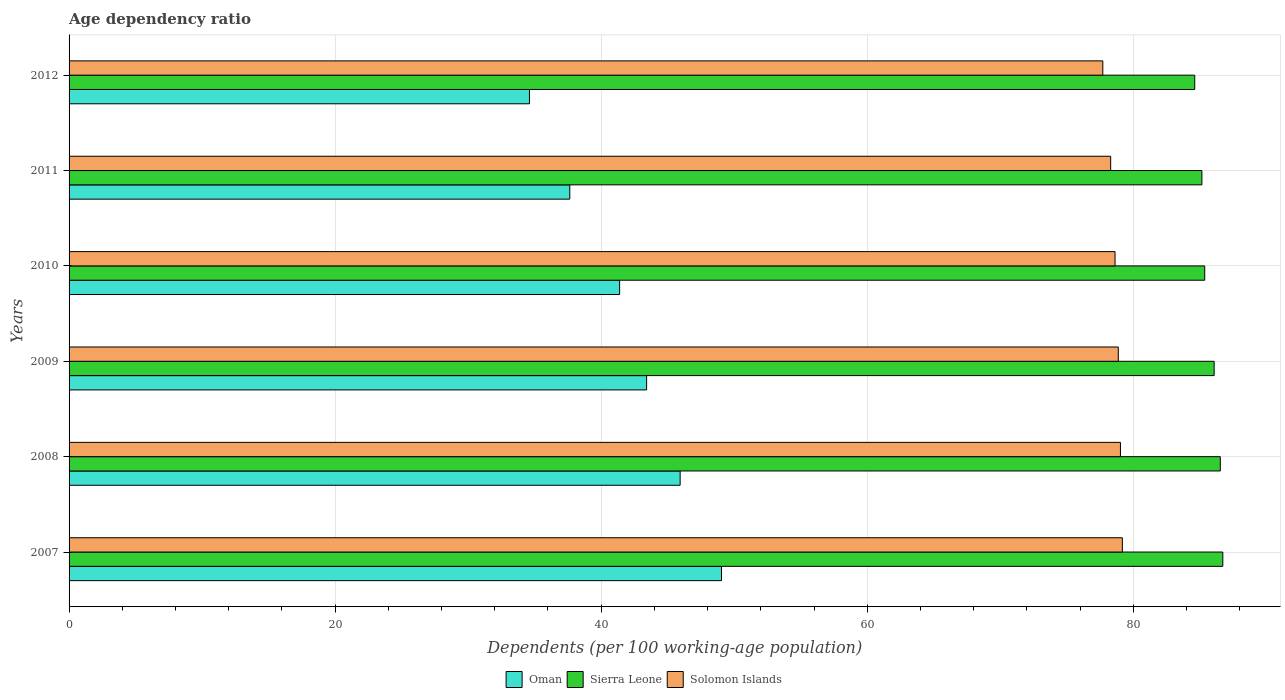How many different coloured bars are there?
Keep it short and to the point. 3. How many groups of bars are there?
Provide a short and direct response. 6. Are the number of bars on each tick of the Y-axis equal?
Provide a short and direct response. Yes. How many bars are there on the 2nd tick from the top?
Provide a succinct answer. 3. What is the label of the 1st group of bars from the top?
Your answer should be very brief. 2012. What is the age dependency ratio in in Solomon Islands in 2009?
Your answer should be compact. 78.87. Across all years, what is the maximum age dependency ratio in in Solomon Islands?
Provide a short and direct response. 79.18. Across all years, what is the minimum age dependency ratio in in Solomon Islands?
Make the answer very short. 77.71. In which year was the age dependency ratio in in Solomon Islands minimum?
Provide a succinct answer. 2012. What is the total age dependency ratio in in Oman in the graph?
Offer a terse response. 252.03. What is the difference between the age dependency ratio in in Oman in 2008 and that in 2009?
Provide a short and direct response. 2.52. What is the difference between the age dependency ratio in in Sierra Leone in 2010 and the age dependency ratio in in Oman in 2011?
Offer a very short reply. 47.73. What is the average age dependency ratio in in Solomon Islands per year?
Offer a terse response. 78.62. In the year 2010, what is the difference between the age dependency ratio in in Solomon Islands and age dependency ratio in in Sierra Leone?
Offer a very short reply. -6.74. In how many years, is the age dependency ratio in in Solomon Islands greater than 64 %?
Offer a terse response. 6. What is the ratio of the age dependency ratio in in Solomon Islands in 2009 to that in 2010?
Give a very brief answer. 1. Is the age dependency ratio in in Oman in 2009 less than that in 2011?
Give a very brief answer. No. Is the difference between the age dependency ratio in in Solomon Islands in 2007 and 2010 greater than the difference between the age dependency ratio in in Sierra Leone in 2007 and 2010?
Your answer should be very brief. No. What is the difference between the highest and the second highest age dependency ratio in in Sierra Leone?
Make the answer very short. 0.19. What is the difference between the highest and the lowest age dependency ratio in in Oman?
Your answer should be very brief. 14.44. Is the sum of the age dependency ratio in in Sierra Leone in 2010 and 2012 greater than the maximum age dependency ratio in in Oman across all years?
Provide a short and direct response. Yes. What does the 2nd bar from the top in 2012 represents?
Your answer should be very brief. Sierra Leone. What does the 1st bar from the bottom in 2012 represents?
Keep it short and to the point. Oman. How many bars are there?
Ensure brevity in your answer.  18. Are all the bars in the graph horizontal?
Your answer should be very brief. Yes. Are the values on the major ticks of X-axis written in scientific E-notation?
Provide a succinct answer. No. Where does the legend appear in the graph?
Give a very brief answer. Bottom center. What is the title of the graph?
Your answer should be compact. Age dependency ratio. Does "Jamaica" appear as one of the legend labels in the graph?
Give a very brief answer. No. What is the label or title of the X-axis?
Ensure brevity in your answer.  Dependents (per 100 working-age population). What is the Dependents (per 100 working-age population) in Oman in 2007?
Provide a short and direct response. 49.05. What is the Dependents (per 100 working-age population) of Sierra Leone in 2007?
Your answer should be very brief. 86.73. What is the Dependents (per 100 working-age population) of Solomon Islands in 2007?
Your response must be concise. 79.18. What is the Dependents (per 100 working-age population) in Oman in 2008?
Your answer should be compact. 45.94. What is the Dependents (per 100 working-age population) of Sierra Leone in 2008?
Give a very brief answer. 86.54. What is the Dependents (per 100 working-age population) in Solomon Islands in 2008?
Your answer should be compact. 79.04. What is the Dependents (per 100 working-age population) in Oman in 2009?
Make the answer very short. 43.42. What is the Dependents (per 100 working-age population) in Sierra Leone in 2009?
Your response must be concise. 86.08. What is the Dependents (per 100 working-age population) of Solomon Islands in 2009?
Provide a short and direct response. 78.87. What is the Dependents (per 100 working-age population) of Oman in 2010?
Your answer should be very brief. 41.39. What is the Dependents (per 100 working-age population) in Sierra Leone in 2010?
Keep it short and to the point. 85.37. What is the Dependents (per 100 working-age population) of Solomon Islands in 2010?
Offer a terse response. 78.63. What is the Dependents (per 100 working-age population) of Oman in 2011?
Offer a very short reply. 37.64. What is the Dependents (per 100 working-age population) in Sierra Leone in 2011?
Keep it short and to the point. 85.16. What is the Dependents (per 100 working-age population) in Solomon Islands in 2011?
Ensure brevity in your answer.  78.3. What is the Dependents (per 100 working-age population) in Oman in 2012?
Your answer should be compact. 34.61. What is the Dependents (per 100 working-age population) of Sierra Leone in 2012?
Your answer should be very brief. 84.62. What is the Dependents (per 100 working-age population) in Solomon Islands in 2012?
Provide a short and direct response. 77.71. Across all years, what is the maximum Dependents (per 100 working-age population) in Oman?
Provide a short and direct response. 49.05. Across all years, what is the maximum Dependents (per 100 working-age population) of Sierra Leone?
Give a very brief answer. 86.73. Across all years, what is the maximum Dependents (per 100 working-age population) of Solomon Islands?
Give a very brief answer. 79.18. Across all years, what is the minimum Dependents (per 100 working-age population) of Oman?
Offer a terse response. 34.61. Across all years, what is the minimum Dependents (per 100 working-age population) of Sierra Leone?
Your answer should be very brief. 84.62. Across all years, what is the minimum Dependents (per 100 working-age population) in Solomon Islands?
Your response must be concise. 77.71. What is the total Dependents (per 100 working-age population) of Oman in the graph?
Keep it short and to the point. 252.03. What is the total Dependents (per 100 working-age population) in Sierra Leone in the graph?
Make the answer very short. 514.5. What is the total Dependents (per 100 working-age population) in Solomon Islands in the graph?
Your answer should be compact. 471.73. What is the difference between the Dependents (per 100 working-age population) in Oman in 2007 and that in 2008?
Your answer should be very brief. 3.11. What is the difference between the Dependents (per 100 working-age population) in Sierra Leone in 2007 and that in 2008?
Your answer should be very brief. 0.19. What is the difference between the Dependents (per 100 working-age population) in Solomon Islands in 2007 and that in 2008?
Your answer should be compact. 0.14. What is the difference between the Dependents (per 100 working-age population) in Oman in 2007 and that in 2009?
Offer a very short reply. 5.63. What is the difference between the Dependents (per 100 working-age population) in Sierra Leone in 2007 and that in 2009?
Keep it short and to the point. 0.65. What is the difference between the Dependents (per 100 working-age population) in Solomon Islands in 2007 and that in 2009?
Provide a short and direct response. 0.3. What is the difference between the Dependents (per 100 working-age population) of Oman in 2007 and that in 2010?
Your response must be concise. 7.66. What is the difference between the Dependents (per 100 working-age population) in Sierra Leone in 2007 and that in 2010?
Your answer should be compact. 1.36. What is the difference between the Dependents (per 100 working-age population) of Solomon Islands in 2007 and that in 2010?
Give a very brief answer. 0.55. What is the difference between the Dependents (per 100 working-age population) of Oman in 2007 and that in 2011?
Provide a succinct answer. 11.4. What is the difference between the Dependents (per 100 working-age population) in Sierra Leone in 2007 and that in 2011?
Make the answer very short. 1.57. What is the difference between the Dependents (per 100 working-age population) in Solomon Islands in 2007 and that in 2011?
Your answer should be compact. 0.88. What is the difference between the Dependents (per 100 working-age population) in Oman in 2007 and that in 2012?
Your answer should be compact. 14.44. What is the difference between the Dependents (per 100 working-age population) of Sierra Leone in 2007 and that in 2012?
Give a very brief answer. 2.11. What is the difference between the Dependents (per 100 working-age population) in Solomon Islands in 2007 and that in 2012?
Provide a succinct answer. 1.47. What is the difference between the Dependents (per 100 working-age population) of Oman in 2008 and that in 2009?
Provide a short and direct response. 2.52. What is the difference between the Dependents (per 100 working-age population) in Sierra Leone in 2008 and that in 2009?
Your response must be concise. 0.46. What is the difference between the Dependents (per 100 working-age population) of Solomon Islands in 2008 and that in 2009?
Offer a terse response. 0.16. What is the difference between the Dependents (per 100 working-age population) of Oman in 2008 and that in 2010?
Ensure brevity in your answer.  4.55. What is the difference between the Dependents (per 100 working-age population) in Sierra Leone in 2008 and that in 2010?
Your answer should be compact. 1.17. What is the difference between the Dependents (per 100 working-age population) in Solomon Islands in 2008 and that in 2010?
Offer a very short reply. 0.41. What is the difference between the Dependents (per 100 working-age population) of Oman in 2008 and that in 2011?
Your answer should be very brief. 8.29. What is the difference between the Dependents (per 100 working-age population) in Sierra Leone in 2008 and that in 2011?
Provide a succinct answer. 1.38. What is the difference between the Dependents (per 100 working-age population) of Solomon Islands in 2008 and that in 2011?
Offer a terse response. 0.74. What is the difference between the Dependents (per 100 working-age population) of Oman in 2008 and that in 2012?
Keep it short and to the point. 11.33. What is the difference between the Dependents (per 100 working-age population) in Sierra Leone in 2008 and that in 2012?
Keep it short and to the point. 1.92. What is the difference between the Dependents (per 100 working-age population) of Solomon Islands in 2008 and that in 2012?
Offer a very short reply. 1.33. What is the difference between the Dependents (per 100 working-age population) of Oman in 2009 and that in 2010?
Give a very brief answer. 2.03. What is the difference between the Dependents (per 100 working-age population) of Sierra Leone in 2009 and that in 2010?
Provide a short and direct response. 0.71. What is the difference between the Dependents (per 100 working-age population) of Solomon Islands in 2009 and that in 2010?
Offer a very short reply. 0.25. What is the difference between the Dependents (per 100 working-age population) in Oman in 2009 and that in 2011?
Offer a terse response. 5.78. What is the difference between the Dependents (per 100 working-age population) of Sierra Leone in 2009 and that in 2011?
Your answer should be very brief. 0.92. What is the difference between the Dependents (per 100 working-age population) of Solomon Islands in 2009 and that in 2011?
Ensure brevity in your answer.  0.57. What is the difference between the Dependents (per 100 working-age population) in Oman in 2009 and that in 2012?
Provide a short and direct response. 8.81. What is the difference between the Dependents (per 100 working-age population) of Sierra Leone in 2009 and that in 2012?
Your answer should be very brief. 1.46. What is the difference between the Dependents (per 100 working-age population) of Solomon Islands in 2009 and that in 2012?
Your response must be concise. 1.16. What is the difference between the Dependents (per 100 working-age population) of Oman in 2010 and that in 2011?
Ensure brevity in your answer.  3.75. What is the difference between the Dependents (per 100 working-age population) of Sierra Leone in 2010 and that in 2011?
Your response must be concise. 0.21. What is the difference between the Dependents (per 100 working-age population) in Solomon Islands in 2010 and that in 2011?
Give a very brief answer. 0.33. What is the difference between the Dependents (per 100 working-age population) in Oman in 2010 and that in 2012?
Make the answer very short. 6.78. What is the difference between the Dependents (per 100 working-age population) of Sierra Leone in 2010 and that in 2012?
Your answer should be very brief. 0.75. What is the difference between the Dependents (per 100 working-age population) in Solomon Islands in 2010 and that in 2012?
Provide a succinct answer. 0.92. What is the difference between the Dependents (per 100 working-age population) of Oman in 2011 and that in 2012?
Ensure brevity in your answer.  3.03. What is the difference between the Dependents (per 100 working-age population) in Sierra Leone in 2011 and that in 2012?
Your response must be concise. 0.54. What is the difference between the Dependents (per 100 working-age population) in Solomon Islands in 2011 and that in 2012?
Your answer should be very brief. 0.59. What is the difference between the Dependents (per 100 working-age population) of Oman in 2007 and the Dependents (per 100 working-age population) of Sierra Leone in 2008?
Your response must be concise. -37.5. What is the difference between the Dependents (per 100 working-age population) in Oman in 2007 and the Dependents (per 100 working-age population) in Solomon Islands in 2008?
Provide a short and direct response. -29.99. What is the difference between the Dependents (per 100 working-age population) of Sierra Leone in 2007 and the Dependents (per 100 working-age population) of Solomon Islands in 2008?
Provide a short and direct response. 7.69. What is the difference between the Dependents (per 100 working-age population) in Oman in 2007 and the Dependents (per 100 working-age population) in Sierra Leone in 2009?
Give a very brief answer. -37.04. What is the difference between the Dependents (per 100 working-age population) in Oman in 2007 and the Dependents (per 100 working-age population) in Solomon Islands in 2009?
Offer a very short reply. -29.83. What is the difference between the Dependents (per 100 working-age population) in Sierra Leone in 2007 and the Dependents (per 100 working-age population) in Solomon Islands in 2009?
Make the answer very short. 7.86. What is the difference between the Dependents (per 100 working-age population) in Oman in 2007 and the Dependents (per 100 working-age population) in Sierra Leone in 2010?
Offer a terse response. -36.33. What is the difference between the Dependents (per 100 working-age population) of Oman in 2007 and the Dependents (per 100 working-age population) of Solomon Islands in 2010?
Provide a succinct answer. -29.58. What is the difference between the Dependents (per 100 working-age population) in Sierra Leone in 2007 and the Dependents (per 100 working-age population) in Solomon Islands in 2010?
Keep it short and to the point. 8.1. What is the difference between the Dependents (per 100 working-age population) in Oman in 2007 and the Dependents (per 100 working-age population) in Sierra Leone in 2011?
Your response must be concise. -36.11. What is the difference between the Dependents (per 100 working-age population) of Oman in 2007 and the Dependents (per 100 working-age population) of Solomon Islands in 2011?
Keep it short and to the point. -29.26. What is the difference between the Dependents (per 100 working-age population) in Sierra Leone in 2007 and the Dependents (per 100 working-age population) in Solomon Islands in 2011?
Your response must be concise. 8.43. What is the difference between the Dependents (per 100 working-age population) of Oman in 2007 and the Dependents (per 100 working-age population) of Sierra Leone in 2012?
Ensure brevity in your answer.  -35.57. What is the difference between the Dependents (per 100 working-age population) in Oman in 2007 and the Dependents (per 100 working-age population) in Solomon Islands in 2012?
Ensure brevity in your answer.  -28.66. What is the difference between the Dependents (per 100 working-age population) of Sierra Leone in 2007 and the Dependents (per 100 working-age population) of Solomon Islands in 2012?
Give a very brief answer. 9.02. What is the difference between the Dependents (per 100 working-age population) of Oman in 2008 and the Dependents (per 100 working-age population) of Sierra Leone in 2009?
Make the answer very short. -40.14. What is the difference between the Dependents (per 100 working-age population) of Oman in 2008 and the Dependents (per 100 working-age population) of Solomon Islands in 2009?
Keep it short and to the point. -32.94. What is the difference between the Dependents (per 100 working-age population) of Sierra Leone in 2008 and the Dependents (per 100 working-age population) of Solomon Islands in 2009?
Your answer should be compact. 7.67. What is the difference between the Dependents (per 100 working-age population) of Oman in 2008 and the Dependents (per 100 working-age population) of Sierra Leone in 2010?
Your answer should be compact. -39.44. What is the difference between the Dependents (per 100 working-age population) of Oman in 2008 and the Dependents (per 100 working-age population) of Solomon Islands in 2010?
Offer a very short reply. -32.69. What is the difference between the Dependents (per 100 working-age population) in Sierra Leone in 2008 and the Dependents (per 100 working-age population) in Solomon Islands in 2010?
Your response must be concise. 7.91. What is the difference between the Dependents (per 100 working-age population) of Oman in 2008 and the Dependents (per 100 working-age population) of Sierra Leone in 2011?
Give a very brief answer. -39.22. What is the difference between the Dependents (per 100 working-age population) in Oman in 2008 and the Dependents (per 100 working-age population) in Solomon Islands in 2011?
Your answer should be compact. -32.37. What is the difference between the Dependents (per 100 working-age population) in Sierra Leone in 2008 and the Dependents (per 100 working-age population) in Solomon Islands in 2011?
Give a very brief answer. 8.24. What is the difference between the Dependents (per 100 working-age population) in Oman in 2008 and the Dependents (per 100 working-age population) in Sierra Leone in 2012?
Ensure brevity in your answer.  -38.68. What is the difference between the Dependents (per 100 working-age population) in Oman in 2008 and the Dependents (per 100 working-age population) in Solomon Islands in 2012?
Your answer should be compact. -31.77. What is the difference between the Dependents (per 100 working-age population) of Sierra Leone in 2008 and the Dependents (per 100 working-age population) of Solomon Islands in 2012?
Offer a very short reply. 8.83. What is the difference between the Dependents (per 100 working-age population) in Oman in 2009 and the Dependents (per 100 working-age population) in Sierra Leone in 2010?
Your answer should be compact. -41.96. What is the difference between the Dependents (per 100 working-age population) in Oman in 2009 and the Dependents (per 100 working-age population) in Solomon Islands in 2010?
Offer a very short reply. -35.21. What is the difference between the Dependents (per 100 working-age population) in Sierra Leone in 2009 and the Dependents (per 100 working-age population) in Solomon Islands in 2010?
Ensure brevity in your answer.  7.45. What is the difference between the Dependents (per 100 working-age population) in Oman in 2009 and the Dependents (per 100 working-age population) in Sierra Leone in 2011?
Give a very brief answer. -41.74. What is the difference between the Dependents (per 100 working-age population) of Oman in 2009 and the Dependents (per 100 working-age population) of Solomon Islands in 2011?
Give a very brief answer. -34.88. What is the difference between the Dependents (per 100 working-age population) in Sierra Leone in 2009 and the Dependents (per 100 working-age population) in Solomon Islands in 2011?
Ensure brevity in your answer.  7.78. What is the difference between the Dependents (per 100 working-age population) in Oman in 2009 and the Dependents (per 100 working-age population) in Sierra Leone in 2012?
Offer a very short reply. -41.2. What is the difference between the Dependents (per 100 working-age population) in Oman in 2009 and the Dependents (per 100 working-age population) in Solomon Islands in 2012?
Provide a succinct answer. -34.29. What is the difference between the Dependents (per 100 working-age population) in Sierra Leone in 2009 and the Dependents (per 100 working-age population) in Solomon Islands in 2012?
Your answer should be compact. 8.37. What is the difference between the Dependents (per 100 working-age population) of Oman in 2010 and the Dependents (per 100 working-age population) of Sierra Leone in 2011?
Offer a very short reply. -43.77. What is the difference between the Dependents (per 100 working-age population) of Oman in 2010 and the Dependents (per 100 working-age population) of Solomon Islands in 2011?
Your answer should be compact. -36.91. What is the difference between the Dependents (per 100 working-age population) of Sierra Leone in 2010 and the Dependents (per 100 working-age population) of Solomon Islands in 2011?
Make the answer very short. 7.07. What is the difference between the Dependents (per 100 working-age population) of Oman in 2010 and the Dependents (per 100 working-age population) of Sierra Leone in 2012?
Give a very brief answer. -43.23. What is the difference between the Dependents (per 100 working-age population) of Oman in 2010 and the Dependents (per 100 working-age population) of Solomon Islands in 2012?
Make the answer very short. -36.32. What is the difference between the Dependents (per 100 working-age population) in Sierra Leone in 2010 and the Dependents (per 100 working-age population) in Solomon Islands in 2012?
Provide a succinct answer. 7.66. What is the difference between the Dependents (per 100 working-age population) in Oman in 2011 and the Dependents (per 100 working-age population) in Sierra Leone in 2012?
Your answer should be very brief. -46.98. What is the difference between the Dependents (per 100 working-age population) of Oman in 2011 and the Dependents (per 100 working-age population) of Solomon Islands in 2012?
Your answer should be compact. -40.07. What is the difference between the Dependents (per 100 working-age population) in Sierra Leone in 2011 and the Dependents (per 100 working-age population) in Solomon Islands in 2012?
Provide a succinct answer. 7.45. What is the average Dependents (per 100 working-age population) of Oman per year?
Ensure brevity in your answer.  42.01. What is the average Dependents (per 100 working-age population) in Sierra Leone per year?
Provide a succinct answer. 85.75. What is the average Dependents (per 100 working-age population) of Solomon Islands per year?
Ensure brevity in your answer.  78.62. In the year 2007, what is the difference between the Dependents (per 100 working-age population) of Oman and Dependents (per 100 working-age population) of Sierra Leone?
Give a very brief answer. -37.69. In the year 2007, what is the difference between the Dependents (per 100 working-age population) in Oman and Dependents (per 100 working-age population) in Solomon Islands?
Offer a terse response. -30.13. In the year 2007, what is the difference between the Dependents (per 100 working-age population) of Sierra Leone and Dependents (per 100 working-age population) of Solomon Islands?
Make the answer very short. 7.55. In the year 2008, what is the difference between the Dependents (per 100 working-age population) in Oman and Dependents (per 100 working-age population) in Sierra Leone?
Your answer should be very brief. -40.61. In the year 2008, what is the difference between the Dependents (per 100 working-age population) of Oman and Dependents (per 100 working-age population) of Solomon Islands?
Provide a succinct answer. -33.1. In the year 2008, what is the difference between the Dependents (per 100 working-age population) in Sierra Leone and Dependents (per 100 working-age population) in Solomon Islands?
Provide a succinct answer. 7.51. In the year 2009, what is the difference between the Dependents (per 100 working-age population) in Oman and Dependents (per 100 working-age population) in Sierra Leone?
Provide a short and direct response. -42.66. In the year 2009, what is the difference between the Dependents (per 100 working-age population) in Oman and Dependents (per 100 working-age population) in Solomon Islands?
Offer a terse response. -35.46. In the year 2009, what is the difference between the Dependents (per 100 working-age population) of Sierra Leone and Dependents (per 100 working-age population) of Solomon Islands?
Make the answer very short. 7.21. In the year 2010, what is the difference between the Dependents (per 100 working-age population) in Oman and Dependents (per 100 working-age population) in Sierra Leone?
Offer a terse response. -43.98. In the year 2010, what is the difference between the Dependents (per 100 working-age population) of Oman and Dependents (per 100 working-age population) of Solomon Islands?
Provide a short and direct response. -37.24. In the year 2010, what is the difference between the Dependents (per 100 working-age population) of Sierra Leone and Dependents (per 100 working-age population) of Solomon Islands?
Provide a succinct answer. 6.74. In the year 2011, what is the difference between the Dependents (per 100 working-age population) of Oman and Dependents (per 100 working-age population) of Sierra Leone?
Give a very brief answer. -47.52. In the year 2011, what is the difference between the Dependents (per 100 working-age population) of Oman and Dependents (per 100 working-age population) of Solomon Islands?
Provide a short and direct response. -40.66. In the year 2011, what is the difference between the Dependents (per 100 working-age population) in Sierra Leone and Dependents (per 100 working-age population) in Solomon Islands?
Your answer should be compact. 6.86. In the year 2012, what is the difference between the Dependents (per 100 working-age population) of Oman and Dependents (per 100 working-age population) of Sierra Leone?
Provide a succinct answer. -50.01. In the year 2012, what is the difference between the Dependents (per 100 working-age population) of Oman and Dependents (per 100 working-age population) of Solomon Islands?
Provide a short and direct response. -43.1. In the year 2012, what is the difference between the Dependents (per 100 working-age population) in Sierra Leone and Dependents (per 100 working-age population) in Solomon Islands?
Your response must be concise. 6.91. What is the ratio of the Dependents (per 100 working-age population) of Oman in 2007 to that in 2008?
Keep it short and to the point. 1.07. What is the ratio of the Dependents (per 100 working-age population) of Sierra Leone in 2007 to that in 2008?
Keep it short and to the point. 1. What is the ratio of the Dependents (per 100 working-age population) of Oman in 2007 to that in 2009?
Your answer should be very brief. 1.13. What is the ratio of the Dependents (per 100 working-age population) in Sierra Leone in 2007 to that in 2009?
Provide a succinct answer. 1.01. What is the ratio of the Dependents (per 100 working-age population) in Oman in 2007 to that in 2010?
Offer a terse response. 1.19. What is the ratio of the Dependents (per 100 working-age population) in Sierra Leone in 2007 to that in 2010?
Keep it short and to the point. 1.02. What is the ratio of the Dependents (per 100 working-age population) in Solomon Islands in 2007 to that in 2010?
Your answer should be compact. 1.01. What is the ratio of the Dependents (per 100 working-age population) in Oman in 2007 to that in 2011?
Provide a succinct answer. 1.3. What is the ratio of the Dependents (per 100 working-age population) in Sierra Leone in 2007 to that in 2011?
Give a very brief answer. 1.02. What is the ratio of the Dependents (per 100 working-age population) in Solomon Islands in 2007 to that in 2011?
Ensure brevity in your answer.  1.01. What is the ratio of the Dependents (per 100 working-age population) of Oman in 2007 to that in 2012?
Your answer should be very brief. 1.42. What is the ratio of the Dependents (per 100 working-age population) in Sierra Leone in 2007 to that in 2012?
Ensure brevity in your answer.  1.02. What is the ratio of the Dependents (per 100 working-age population) in Solomon Islands in 2007 to that in 2012?
Make the answer very short. 1.02. What is the ratio of the Dependents (per 100 working-age population) in Oman in 2008 to that in 2009?
Offer a terse response. 1.06. What is the ratio of the Dependents (per 100 working-age population) in Sierra Leone in 2008 to that in 2009?
Provide a short and direct response. 1.01. What is the ratio of the Dependents (per 100 working-age population) of Solomon Islands in 2008 to that in 2009?
Your answer should be compact. 1. What is the ratio of the Dependents (per 100 working-age population) of Oman in 2008 to that in 2010?
Keep it short and to the point. 1.11. What is the ratio of the Dependents (per 100 working-age population) in Sierra Leone in 2008 to that in 2010?
Your response must be concise. 1.01. What is the ratio of the Dependents (per 100 working-age population) of Solomon Islands in 2008 to that in 2010?
Your answer should be compact. 1.01. What is the ratio of the Dependents (per 100 working-age population) in Oman in 2008 to that in 2011?
Offer a very short reply. 1.22. What is the ratio of the Dependents (per 100 working-age population) of Sierra Leone in 2008 to that in 2011?
Give a very brief answer. 1.02. What is the ratio of the Dependents (per 100 working-age population) in Solomon Islands in 2008 to that in 2011?
Provide a short and direct response. 1.01. What is the ratio of the Dependents (per 100 working-age population) of Oman in 2008 to that in 2012?
Ensure brevity in your answer.  1.33. What is the ratio of the Dependents (per 100 working-age population) of Sierra Leone in 2008 to that in 2012?
Ensure brevity in your answer.  1.02. What is the ratio of the Dependents (per 100 working-age population) in Solomon Islands in 2008 to that in 2012?
Offer a very short reply. 1.02. What is the ratio of the Dependents (per 100 working-age population) in Oman in 2009 to that in 2010?
Keep it short and to the point. 1.05. What is the ratio of the Dependents (per 100 working-age population) of Sierra Leone in 2009 to that in 2010?
Ensure brevity in your answer.  1.01. What is the ratio of the Dependents (per 100 working-age population) in Oman in 2009 to that in 2011?
Offer a terse response. 1.15. What is the ratio of the Dependents (per 100 working-age population) of Sierra Leone in 2009 to that in 2011?
Make the answer very short. 1.01. What is the ratio of the Dependents (per 100 working-age population) in Solomon Islands in 2009 to that in 2011?
Ensure brevity in your answer.  1.01. What is the ratio of the Dependents (per 100 working-age population) of Oman in 2009 to that in 2012?
Keep it short and to the point. 1.25. What is the ratio of the Dependents (per 100 working-age population) of Sierra Leone in 2009 to that in 2012?
Make the answer very short. 1.02. What is the ratio of the Dependents (per 100 working-age population) of Oman in 2010 to that in 2011?
Your answer should be very brief. 1.1. What is the ratio of the Dependents (per 100 working-age population) of Sierra Leone in 2010 to that in 2011?
Provide a short and direct response. 1. What is the ratio of the Dependents (per 100 working-age population) in Solomon Islands in 2010 to that in 2011?
Your answer should be very brief. 1. What is the ratio of the Dependents (per 100 working-age population) in Oman in 2010 to that in 2012?
Your response must be concise. 1.2. What is the ratio of the Dependents (per 100 working-age population) in Sierra Leone in 2010 to that in 2012?
Ensure brevity in your answer.  1.01. What is the ratio of the Dependents (per 100 working-age population) in Solomon Islands in 2010 to that in 2012?
Keep it short and to the point. 1.01. What is the ratio of the Dependents (per 100 working-age population) of Oman in 2011 to that in 2012?
Provide a succinct answer. 1.09. What is the ratio of the Dependents (per 100 working-age population) of Sierra Leone in 2011 to that in 2012?
Your answer should be very brief. 1.01. What is the ratio of the Dependents (per 100 working-age population) in Solomon Islands in 2011 to that in 2012?
Ensure brevity in your answer.  1.01. What is the difference between the highest and the second highest Dependents (per 100 working-age population) of Oman?
Your answer should be compact. 3.11. What is the difference between the highest and the second highest Dependents (per 100 working-age population) of Sierra Leone?
Provide a short and direct response. 0.19. What is the difference between the highest and the second highest Dependents (per 100 working-age population) in Solomon Islands?
Your answer should be compact. 0.14. What is the difference between the highest and the lowest Dependents (per 100 working-age population) of Oman?
Offer a terse response. 14.44. What is the difference between the highest and the lowest Dependents (per 100 working-age population) in Sierra Leone?
Your response must be concise. 2.11. What is the difference between the highest and the lowest Dependents (per 100 working-age population) in Solomon Islands?
Your response must be concise. 1.47. 